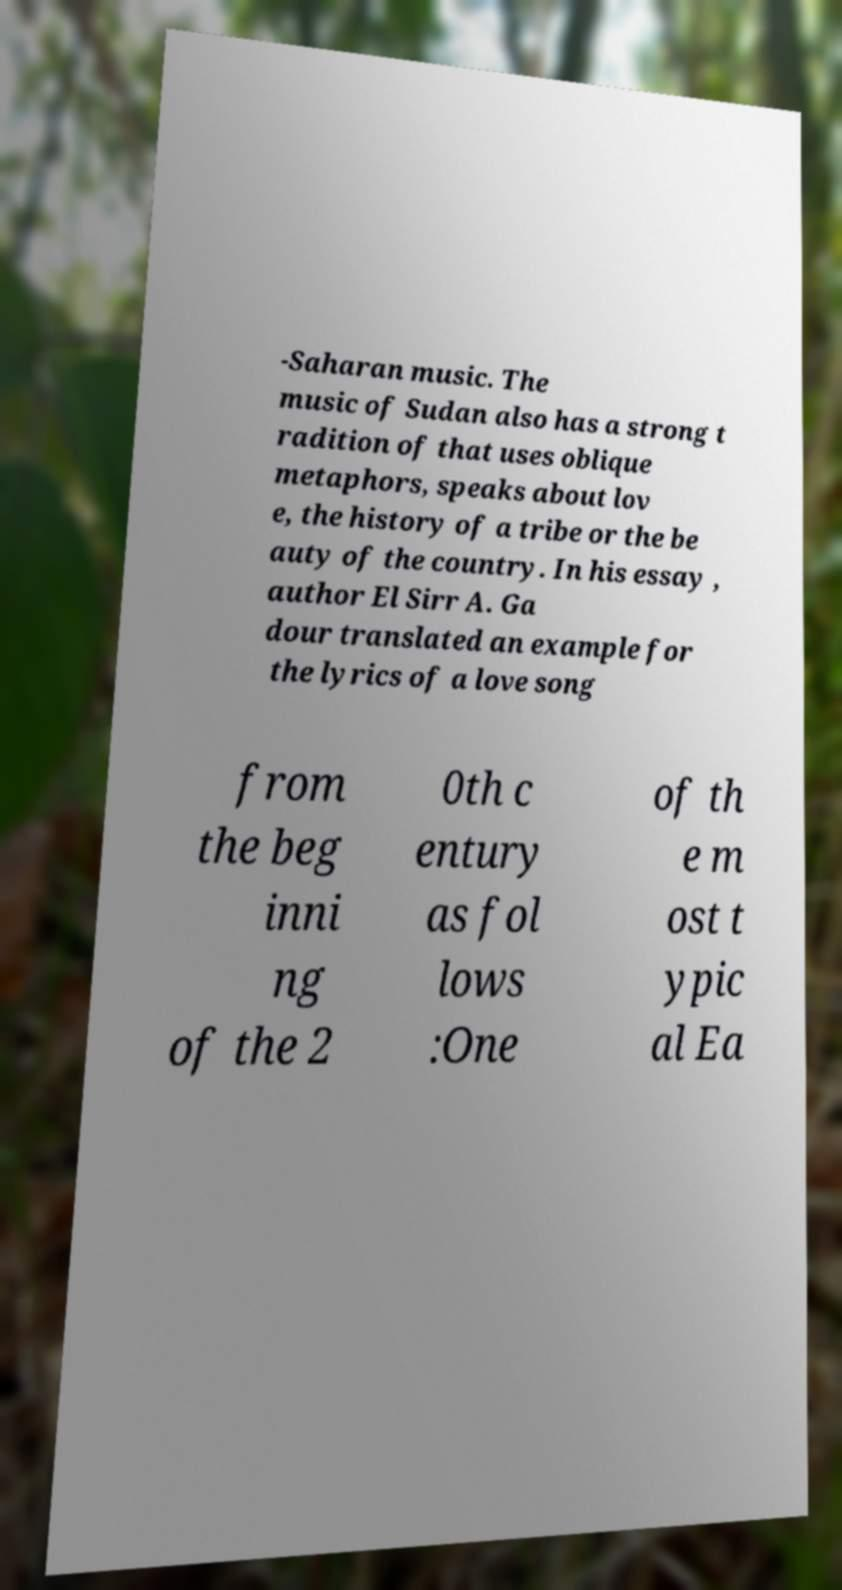What messages or text are displayed in this image? I need them in a readable, typed format. -Saharan music. The music of Sudan also has a strong t radition of that uses oblique metaphors, speaks about lov e, the history of a tribe or the be auty of the country. In his essay , author El Sirr A. Ga dour translated an example for the lyrics of a love song from the beg inni ng of the 2 0th c entury as fol lows :One of th e m ost t ypic al Ea 